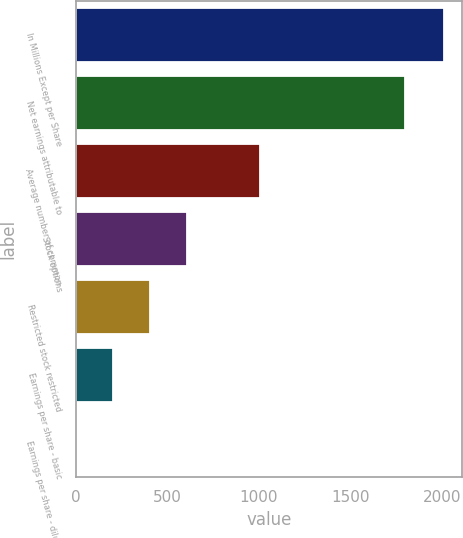Convert chart to OTSL. <chart><loc_0><loc_0><loc_500><loc_500><bar_chart><fcel>In Millions Except per Share<fcel>Net earnings attributable to<fcel>Average number of common<fcel>Stock options<fcel>Restricted stock restricted<fcel>Earnings per share - basic<fcel>Earnings per share - diluted<nl><fcel>2011<fcel>1798.3<fcel>1006.85<fcel>605.19<fcel>404.36<fcel>203.53<fcel>2.7<nl></chart> 